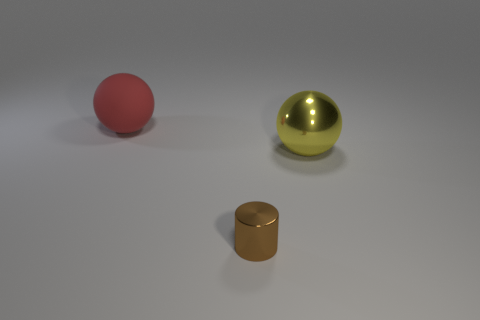Add 3 tiny cylinders. How many objects exist? 6 Subtract all spheres. How many objects are left? 1 Subtract 0 cyan balls. How many objects are left? 3 Subtract all yellow metallic balls. Subtract all metal spheres. How many objects are left? 1 Add 1 big rubber balls. How many big rubber balls are left? 2 Add 3 brown shiny cylinders. How many brown shiny cylinders exist? 4 